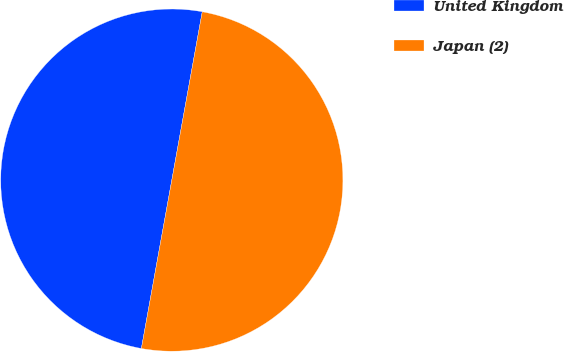<chart> <loc_0><loc_0><loc_500><loc_500><pie_chart><fcel>United Kingdom<fcel>Japan (2)<nl><fcel>50.0%<fcel>50.0%<nl></chart> 